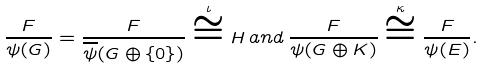<formula> <loc_0><loc_0><loc_500><loc_500>\frac { F } { \psi ( G ) } = \frac { F } { \overline { \psi } ( G \oplus \{ 0 \} ) } \overset { \iota } \cong H \, a n d \, \frac { F } { \psi ( G \oplus K ) } \overset { \kappa } \cong \frac { F } { \psi { ( E ) } } .</formula> 